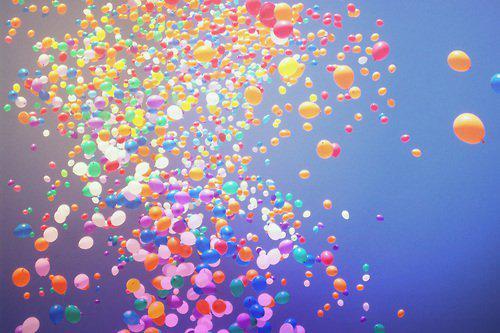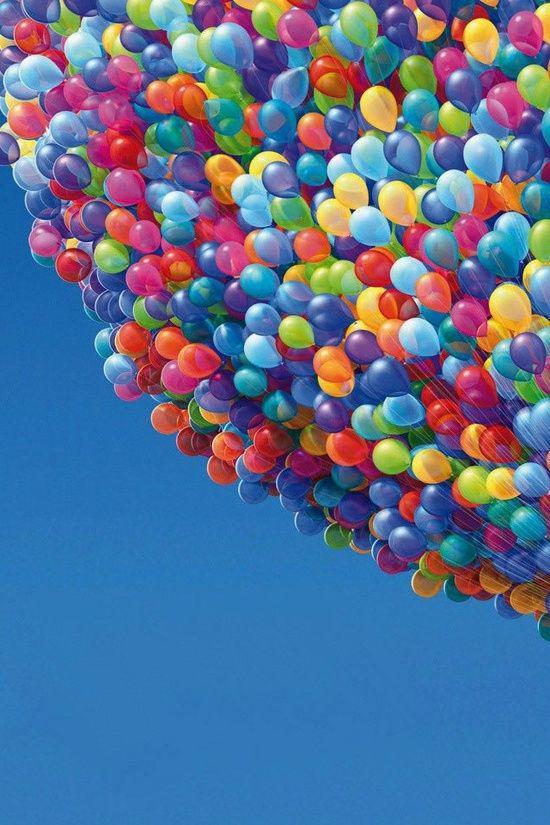The first image is the image on the left, the second image is the image on the right. Given the left and right images, does the statement "Balloons float in the air in one of the images." hold true? Answer yes or no. Yes. The first image is the image on the left, the second image is the image on the right. Evaluate the accuracy of this statement regarding the images: "In at least one image there are hundreds of balloons being released into the sky.". Is it true? Answer yes or no. Yes. 